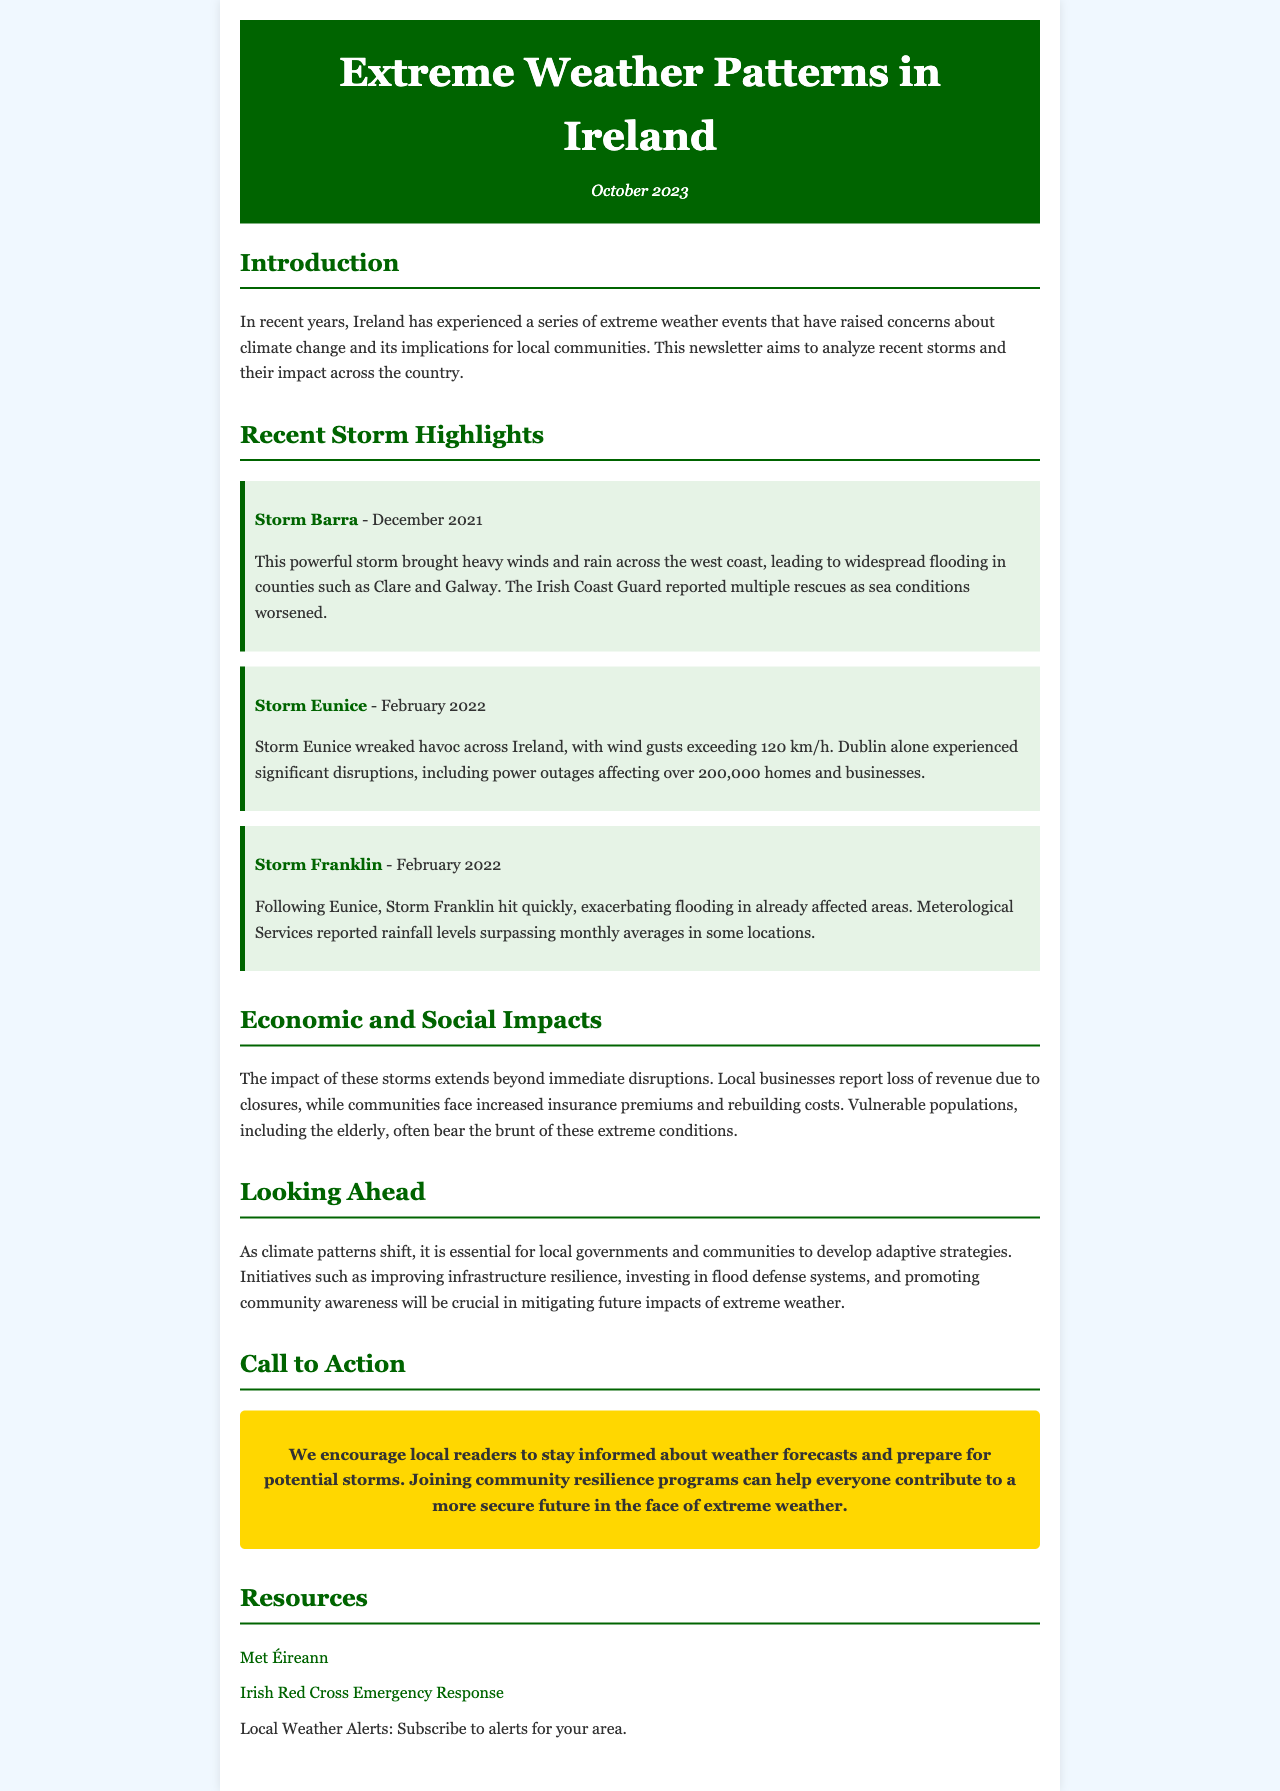What is the title of the newsletter? The title of the newsletter is stated in the header of the document.
Answer: Extreme Weather Patterns in Ireland When was this newsletter issued? The issue date is mentioned below the title in the header section.
Answer: October 2023 What storm caused widespread flooding in counties Clare and Galway? The details of the storms are highlighted in sections that describe their impacts.
Answer: Storm Barra What wind speed did Storm Eunice exceed? The document specifies the wind gusts that were recorded during Storm Eunice.
Answer: 120 km/h What significant event occurred as a result of Storm Eunice in Dublin? The document outlines the effects of Storm Eunice, particularly in Dublin.
Answer: Power outages What are two suggested initiatives to prepare for future extreme weather? The document discusses adaptive strategies for local governments and communities.
Answer: Improving infrastructure resilience, investing in flood defense systems Which organization provides local weather alerts? The resources section provides links and information about organizations related to weather.
Answer: Met Éireann What is a notable impact on local businesses due to recent storms? The economic impacts of storms on businesses are discussed in the respective section.
Answer: Loss of revenue 